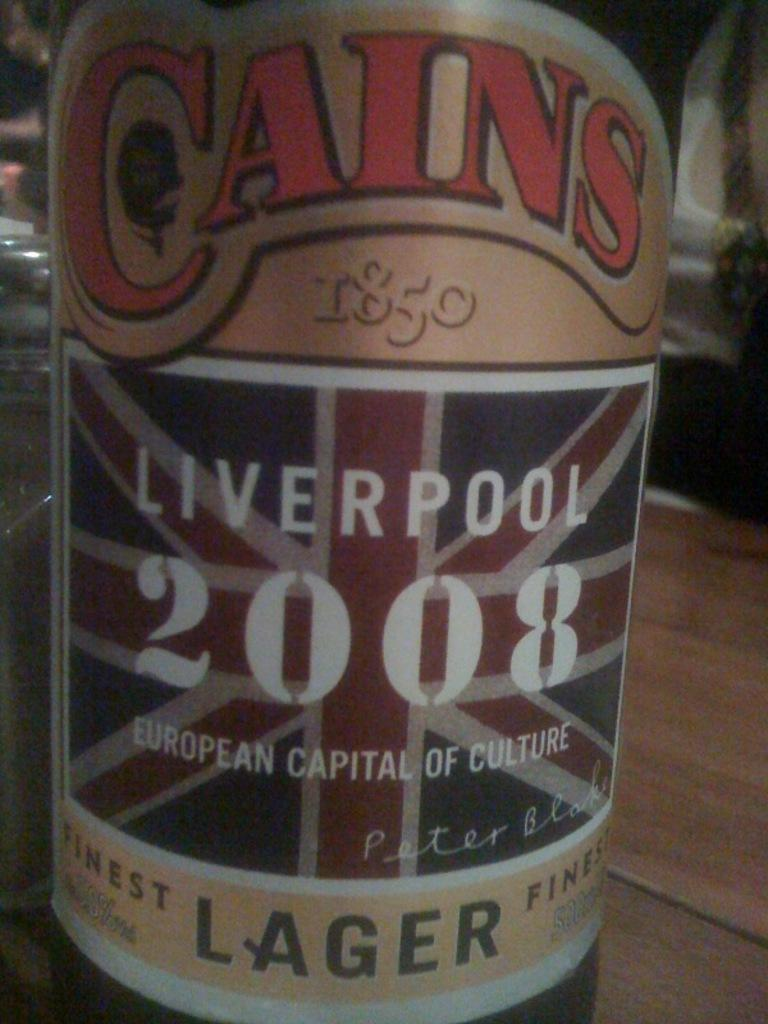<image>
Provide a brief description of the given image. A bottle of Cains  Liverpool lager is from 2008. 